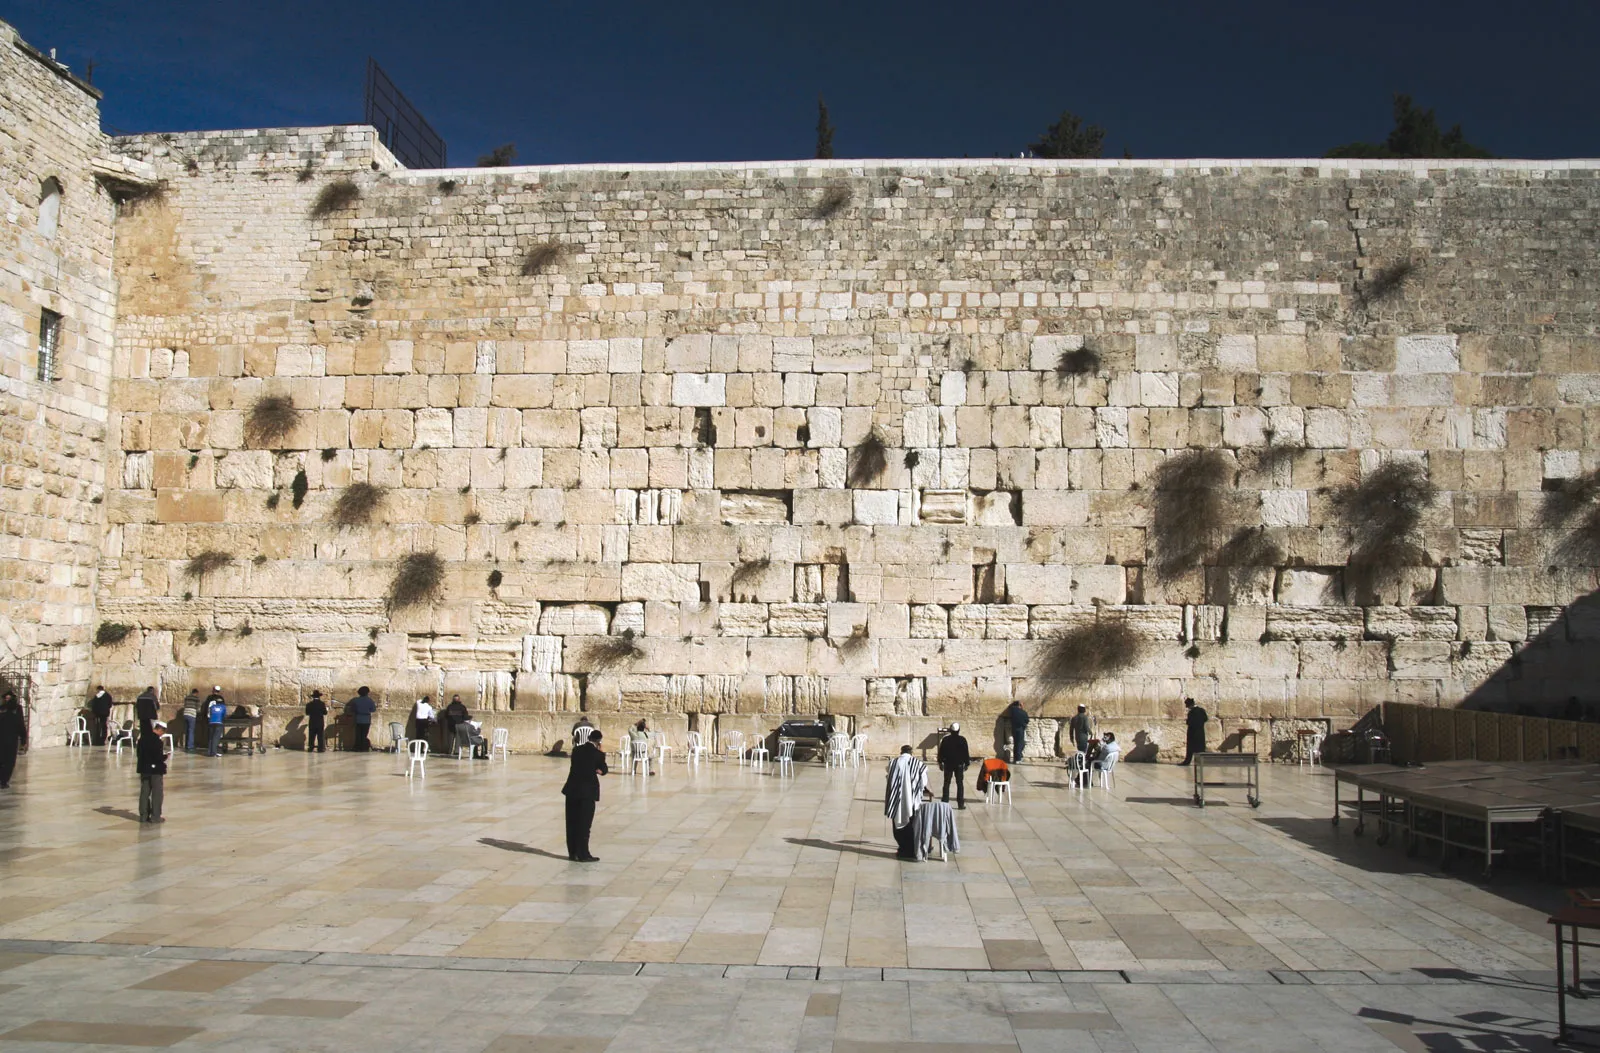Explain the visual content of the image in great detail. The image shows a broad and up-close view of the Wailing Wall, also known as the Western Wall, in Jerusalem, Israel. This ancient limestone wall, weathered and beige-colored, features stones of varying sizes and states, some smooth while others are deeply crevassed, interspersed with tufts of vegetation. The plaza before the wall is spacious and paved with uniform grey tiles, filled with individuals engaged in prayer, contemplation, and discussion. Notably, men, often in distinct orthodox Jewish attire, are seen near the wall itself, while others might be tourists, identifiable by their casual dress. Several groups can be noticed seated on chairs or standing in small groups, possibly discussing religious or historical contexts. Above the wall, a clear blue sky provides a serene backdrop, enhancing the solemn atmospheric tone of this spiritual site. 